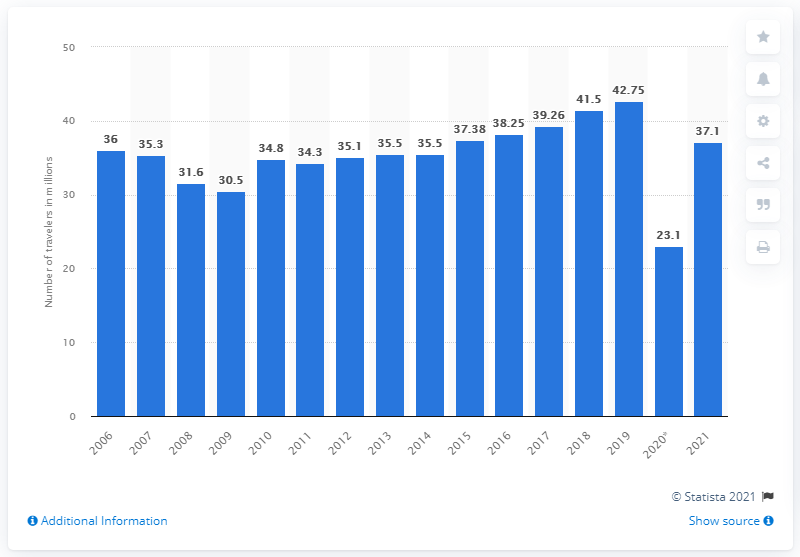Outline some significant characteristics in this image. During the Memorial Day holiday period in 2021, it was forecasted that 37.1 percent of Americans would take a trip. 